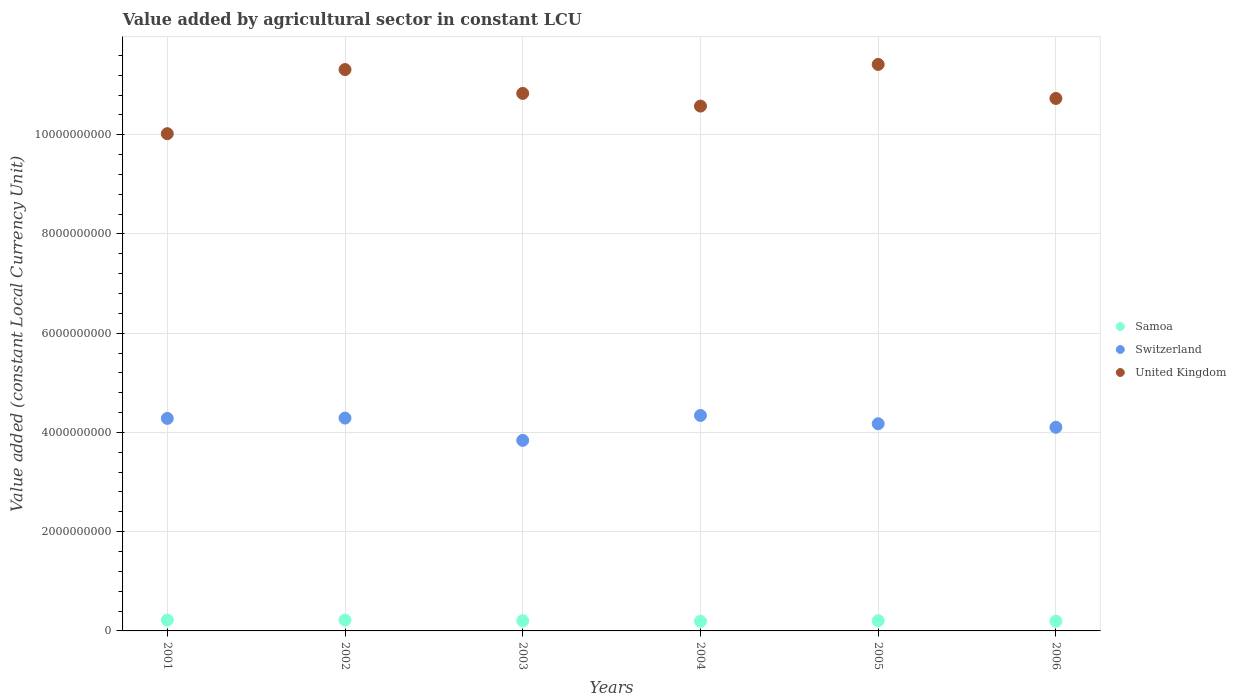How many different coloured dotlines are there?
Your response must be concise. 3. Is the number of dotlines equal to the number of legend labels?
Your response must be concise. Yes. What is the value added by agricultural sector in United Kingdom in 2001?
Offer a very short reply. 1.00e+1. Across all years, what is the maximum value added by agricultural sector in United Kingdom?
Your answer should be very brief. 1.14e+1. Across all years, what is the minimum value added by agricultural sector in Samoa?
Offer a very short reply. 1.95e+08. In which year was the value added by agricultural sector in Switzerland minimum?
Ensure brevity in your answer.  2003. What is the total value added by agricultural sector in United Kingdom in the graph?
Your answer should be very brief. 6.49e+1. What is the difference between the value added by agricultural sector in United Kingdom in 2001 and that in 2005?
Give a very brief answer. -1.40e+09. What is the difference between the value added by agricultural sector in Switzerland in 2006 and the value added by agricultural sector in United Kingdom in 2004?
Make the answer very short. -6.47e+09. What is the average value added by agricultural sector in Samoa per year?
Give a very brief answer. 2.07e+08. In the year 2002, what is the difference between the value added by agricultural sector in Switzerland and value added by agricultural sector in Samoa?
Provide a succinct answer. 4.07e+09. What is the ratio of the value added by agricultural sector in Switzerland in 2004 to that in 2006?
Offer a very short reply. 1.06. What is the difference between the highest and the second highest value added by agricultural sector in Samoa?
Your response must be concise. 2.29e+05. What is the difference between the highest and the lowest value added by agricultural sector in Switzerland?
Provide a short and direct response. 5.02e+08. Is it the case that in every year, the sum of the value added by agricultural sector in Switzerland and value added by agricultural sector in United Kingdom  is greater than the value added by agricultural sector in Samoa?
Your response must be concise. Yes. Does the value added by agricultural sector in Samoa monotonically increase over the years?
Keep it short and to the point. No. Is the value added by agricultural sector in Samoa strictly greater than the value added by agricultural sector in United Kingdom over the years?
Your response must be concise. No. Is the value added by agricultural sector in Switzerland strictly less than the value added by agricultural sector in Samoa over the years?
Offer a very short reply. No. How many dotlines are there?
Your answer should be very brief. 3. What is the difference between two consecutive major ticks on the Y-axis?
Offer a very short reply. 2.00e+09. Are the values on the major ticks of Y-axis written in scientific E-notation?
Provide a short and direct response. No. Does the graph contain grids?
Ensure brevity in your answer.  Yes. How many legend labels are there?
Provide a succinct answer. 3. How are the legend labels stacked?
Your answer should be very brief. Vertical. What is the title of the graph?
Make the answer very short. Value added by agricultural sector in constant LCU. Does "Algeria" appear as one of the legend labels in the graph?
Make the answer very short. No. What is the label or title of the Y-axis?
Keep it short and to the point. Value added (constant Local Currency Unit). What is the Value added (constant Local Currency Unit) in Samoa in 2001?
Your answer should be compact. 2.19e+08. What is the Value added (constant Local Currency Unit) in Switzerland in 2001?
Make the answer very short. 4.28e+09. What is the Value added (constant Local Currency Unit) of United Kingdom in 2001?
Keep it short and to the point. 1.00e+1. What is the Value added (constant Local Currency Unit) in Samoa in 2002?
Make the answer very short. 2.19e+08. What is the Value added (constant Local Currency Unit) of Switzerland in 2002?
Make the answer very short. 4.29e+09. What is the Value added (constant Local Currency Unit) in United Kingdom in 2002?
Give a very brief answer. 1.13e+1. What is the Value added (constant Local Currency Unit) in Samoa in 2003?
Offer a terse response. 2.05e+08. What is the Value added (constant Local Currency Unit) in Switzerland in 2003?
Offer a very short reply. 3.84e+09. What is the Value added (constant Local Currency Unit) of United Kingdom in 2003?
Offer a terse response. 1.08e+1. What is the Value added (constant Local Currency Unit) of Samoa in 2004?
Give a very brief answer. 1.95e+08. What is the Value added (constant Local Currency Unit) in Switzerland in 2004?
Provide a succinct answer. 4.34e+09. What is the Value added (constant Local Currency Unit) of United Kingdom in 2004?
Ensure brevity in your answer.  1.06e+1. What is the Value added (constant Local Currency Unit) of Samoa in 2005?
Offer a very short reply. 2.06e+08. What is the Value added (constant Local Currency Unit) of Switzerland in 2005?
Your answer should be very brief. 4.18e+09. What is the Value added (constant Local Currency Unit) of United Kingdom in 2005?
Your response must be concise. 1.14e+1. What is the Value added (constant Local Currency Unit) in Samoa in 2006?
Provide a succinct answer. 1.97e+08. What is the Value added (constant Local Currency Unit) of Switzerland in 2006?
Provide a short and direct response. 4.10e+09. What is the Value added (constant Local Currency Unit) in United Kingdom in 2006?
Offer a terse response. 1.07e+1. Across all years, what is the maximum Value added (constant Local Currency Unit) in Samoa?
Make the answer very short. 2.19e+08. Across all years, what is the maximum Value added (constant Local Currency Unit) of Switzerland?
Provide a succinct answer. 4.34e+09. Across all years, what is the maximum Value added (constant Local Currency Unit) in United Kingdom?
Keep it short and to the point. 1.14e+1. Across all years, what is the minimum Value added (constant Local Currency Unit) in Samoa?
Make the answer very short. 1.95e+08. Across all years, what is the minimum Value added (constant Local Currency Unit) of Switzerland?
Your answer should be very brief. 3.84e+09. Across all years, what is the minimum Value added (constant Local Currency Unit) in United Kingdom?
Offer a very short reply. 1.00e+1. What is the total Value added (constant Local Currency Unit) of Samoa in the graph?
Your answer should be compact. 1.24e+09. What is the total Value added (constant Local Currency Unit) of Switzerland in the graph?
Give a very brief answer. 2.50e+1. What is the total Value added (constant Local Currency Unit) in United Kingdom in the graph?
Your response must be concise. 6.49e+1. What is the difference between the Value added (constant Local Currency Unit) in Samoa in 2001 and that in 2002?
Make the answer very short. 2.29e+05. What is the difference between the Value added (constant Local Currency Unit) of Switzerland in 2001 and that in 2002?
Make the answer very short. -6.54e+06. What is the difference between the Value added (constant Local Currency Unit) in United Kingdom in 2001 and that in 2002?
Make the answer very short. -1.29e+09. What is the difference between the Value added (constant Local Currency Unit) in Samoa in 2001 and that in 2003?
Offer a terse response. 1.41e+07. What is the difference between the Value added (constant Local Currency Unit) of Switzerland in 2001 and that in 2003?
Give a very brief answer. 4.43e+08. What is the difference between the Value added (constant Local Currency Unit) in United Kingdom in 2001 and that in 2003?
Provide a short and direct response. -8.12e+08. What is the difference between the Value added (constant Local Currency Unit) in Samoa in 2001 and that in 2004?
Ensure brevity in your answer.  2.45e+07. What is the difference between the Value added (constant Local Currency Unit) in Switzerland in 2001 and that in 2004?
Keep it short and to the point. -5.92e+07. What is the difference between the Value added (constant Local Currency Unit) in United Kingdom in 2001 and that in 2004?
Offer a very short reply. -5.56e+08. What is the difference between the Value added (constant Local Currency Unit) in Samoa in 2001 and that in 2005?
Provide a short and direct response. 1.35e+07. What is the difference between the Value added (constant Local Currency Unit) of Switzerland in 2001 and that in 2005?
Offer a very short reply. 1.07e+08. What is the difference between the Value added (constant Local Currency Unit) of United Kingdom in 2001 and that in 2005?
Offer a very short reply. -1.40e+09. What is the difference between the Value added (constant Local Currency Unit) in Samoa in 2001 and that in 2006?
Make the answer very short. 2.21e+07. What is the difference between the Value added (constant Local Currency Unit) of Switzerland in 2001 and that in 2006?
Your answer should be compact. 1.80e+08. What is the difference between the Value added (constant Local Currency Unit) in United Kingdom in 2001 and that in 2006?
Your response must be concise. -7.10e+08. What is the difference between the Value added (constant Local Currency Unit) of Samoa in 2002 and that in 2003?
Provide a succinct answer. 1.39e+07. What is the difference between the Value added (constant Local Currency Unit) in Switzerland in 2002 and that in 2003?
Your answer should be very brief. 4.50e+08. What is the difference between the Value added (constant Local Currency Unit) of United Kingdom in 2002 and that in 2003?
Your answer should be very brief. 4.81e+08. What is the difference between the Value added (constant Local Currency Unit) of Samoa in 2002 and that in 2004?
Keep it short and to the point. 2.42e+07. What is the difference between the Value added (constant Local Currency Unit) in Switzerland in 2002 and that in 2004?
Your answer should be very brief. -5.26e+07. What is the difference between the Value added (constant Local Currency Unit) of United Kingdom in 2002 and that in 2004?
Make the answer very short. 7.36e+08. What is the difference between the Value added (constant Local Currency Unit) of Samoa in 2002 and that in 2005?
Offer a terse response. 1.32e+07. What is the difference between the Value added (constant Local Currency Unit) in Switzerland in 2002 and that in 2005?
Your answer should be compact. 1.14e+08. What is the difference between the Value added (constant Local Currency Unit) of United Kingdom in 2002 and that in 2005?
Ensure brevity in your answer.  -1.04e+08. What is the difference between the Value added (constant Local Currency Unit) in Samoa in 2002 and that in 2006?
Your answer should be very brief. 2.19e+07. What is the difference between the Value added (constant Local Currency Unit) in Switzerland in 2002 and that in 2006?
Ensure brevity in your answer.  1.86e+08. What is the difference between the Value added (constant Local Currency Unit) in United Kingdom in 2002 and that in 2006?
Give a very brief answer. 5.82e+08. What is the difference between the Value added (constant Local Currency Unit) of Samoa in 2003 and that in 2004?
Provide a short and direct response. 1.03e+07. What is the difference between the Value added (constant Local Currency Unit) of Switzerland in 2003 and that in 2004?
Offer a very short reply. -5.02e+08. What is the difference between the Value added (constant Local Currency Unit) of United Kingdom in 2003 and that in 2004?
Keep it short and to the point. 2.56e+08. What is the difference between the Value added (constant Local Currency Unit) in Samoa in 2003 and that in 2005?
Provide a succinct answer. -6.86e+05. What is the difference between the Value added (constant Local Currency Unit) of Switzerland in 2003 and that in 2005?
Give a very brief answer. -3.36e+08. What is the difference between the Value added (constant Local Currency Unit) in United Kingdom in 2003 and that in 2005?
Your response must be concise. -5.84e+08. What is the difference between the Value added (constant Local Currency Unit) in Samoa in 2003 and that in 2006?
Give a very brief answer. 8.00e+06. What is the difference between the Value added (constant Local Currency Unit) in Switzerland in 2003 and that in 2006?
Make the answer very short. -2.64e+08. What is the difference between the Value added (constant Local Currency Unit) of United Kingdom in 2003 and that in 2006?
Make the answer very short. 1.02e+08. What is the difference between the Value added (constant Local Currency Unit) in Samoa in 2004 and that in 2005?
Your answer should be very brief. -1.10e+07. What is the difference between the Value added (constant Local Currency Unit) of Switzerland in 2004 and that in 2005?
Your answer should be compact. 1.66e+08. What is the difference between the Value added (constant Local Currency Unit) of United Kingdom in 2004 and that in 2005?
Offer a terse response. -8.40e+08. What is the difference between the Value added (constant Local Currency Unit) in Samoa in 2004 and that in 2006?
Keep it short and to the point. -2.31e+06. What is the difference between the Value added (constant Local Currency Unit) in Switzerland in 2004 and that in 2006?
Ensure brevity in your answer.  2.39e+08. What is the difference between the Value added (constant Local Currency Unit) in United Kingdom in 2004 and that in 2006?
Give a very brief answer. -1.54e+08. What is the difference between the Value added (constant Local Currency Unit) of Samoa in 2005 and that in 2006?
Ensure brevity in your answer.  8.68e+06. What is the difference between the Value added (constant Local Currency Unit) of Switzerland in 2005 and that in 2006?
Give a very brief answer. 7.24e+07. What is the difference between the Value added (constant Local Currency Unit) of United Kingdom in 2005 and that in 2006?
Make the answer very short. 6.86e+08. What is the difference between the Value added (constant Local Currency Unit) in Samoa in 2001 and the Value added (constant Local Currency Unit) in Switzerland in 2002?
Provide a succinct answer. -4.07e+09. What is the difference between the Value added (constant Local Currency Unit) in Samoa in 2001 and the Value added (constant Local Currency Unit) in United Kingdom in 2002?
Offer a terse response. -1.11e+1. What is the difference between the Value added (constant Local Currency Unit) of Switzerland in 2001 and the Value added (constant Local Currency Unit) of United Kingdom in 2002?
Offer a terse response. -7.03e+09. What is the difference between the Value added (constant Local Currency Unit) of Samoa in 2001 and the Value added (constant Local Currency Unit) of Switzerland in 2003?
Your response must be concise. -3.62e+09. What is the difference between the Value added (constant Local Currency Unit) in Samoa in 2001 and the Value added (constant Local Currency Unit) in United Kingdom in 2003?
Make the answer very short. -1.06e+1. What is the difference between the Value added (constant Local Currency Unit) of Switzerland in 2001 and the Value added (constant Local Currency Unit) of United Kingdom in 2003?
Offer a terse response. -6.55e+09. What is the difference between the Value added (constant Local Currency Unit) of Samoa in 2001 and the Value added (constant Local Currency Unit) of Switzerland in 2004?
Your answer should be compact. -4.12e+09. What is the difference between the Value added (constant Local Currency Unit) of Samoa in 2001 and the Value added (constant Local Currency Unit) of United Kingdom in 2004?
Offer a very short reply. -1.04e+1. What is the difference between the Value added (constant Local Currency Unit) of Switzerland in 2001 and the Value added (constant Local Currency Unit) of United Kingdom in 2004?
Provide a succinct answer. -6.29e+09. What is the difference between the Value added (constant Local Currency Unit) in Samoa in 2001 and the Value added (constant Local Currency Unit) in Switzerland in 2005?
Offer a very short reply. -3.96e+09. What is the difference between the Value added (constant Local Currency Unit) of Samoa in 2001 and the Value added (constant Local Currency Unit) of United Kingdom in 2005?
Your answer should be compact. -1.12e+1. What is the difference between the Value added (constant Local Currency Unit) of Switzerland in 2001 and the Value added (constant Local Currency Unit) of United Kingdom in 2005?
Offer a terse response. -7.13e+09. What is the difference between the Value added (constant Local Currency Unit) of Samoa in 2001 and the Value added (constant Local Currency Unit) of Switzerland in 2006?
Give a very brief answer. -3.88e+09. What is the difference between the Value added (constant Local Currency Unit) of Samoa in 2001 and the Value added (constant Local Currency Unit) of United Kingdom in 2006?
Ensure brevity in your answer.  -1.05e+1. What is the difference between the Value added (constant Local Currency Unit) of Switzerland in 2001 and the Value added (constant Local Currency Unit) of United Kingdom in 2006?
Make the answer very short. -6.45e+09. What is the difference between the Value added (constant Local Currency Unit) of Samoa in 2002 and the Value added (constant Local Currency Unit) of Switzerland in 2003?
Keep it short and to the point. -3.62e+09. What is the difference between the Value added (constant Local Currency Unit) of Samoa in 2002 and the Value added (constant Local Currency Unit) of United Kingdom in 2003?
Ensure brevity in your answer.  -1.06e+1. What is the difference between the Value added (constant Local Currency Unit) in Switzerland in 2002 and the Value added (constant Local Currency Unit) in United Kingdom in 2003?
Keep it short and to the point. -6.54e+09. What is the difference between the Value added (constant Local Currency Unit) of Samoa in 2002 and the Value added (constant Local Currency Unit) of Switzerland in 2004?
Offer a very short reply. -4.12e+09. What is the difference between the Value added (constant Local Currency Unit) of Samoa in 2002 and the Value added (constant Local Currency Unit) of United Kingdom in 2004?
Your answer should be compact. -1.04e+1. What is the difference between the Value added (constant Local Currency Unit) of Switzerland in 2002 and the Value added (constant Local Currency Unit) of United Kingdom in 2004?
Give a very brief answer. -6.29e+09. What is the difference between the Value added (constant Local Currency Unit) in Samoa in 2002 and the Value added (constant Local Currency Unit) in Switzerland in 2005?
Ensure brevity in your answer.  -3.96e+09. What is the difference between the Value added (constant Local Currency Unit) of Samoa in 2002 and the Value added (constant Local Currency Unit) of United Kingdom in 2005?
Give a very brief answer. -1.12e+1. What is the difference between the Value added (constant Local Currency Unit) of Switzerland in 2002 and the Value added (constant Local Currency Unit) of United Kingdom in 2005?
Your answer should be compact. -7.13e+09. What is the difference between the Value added (constant Local Currency Unit) of Samoa in 2002 and the Value added (constant Local Currency Unit) of Switzerland in 2006?
Your answer should be very brief. -3.89e+09. What is the difference between the Value added (constant Local Currency Unit) of Samoa in 2002 and the Value added (constant Local Currency Unit) of United Kingdom in 2006?
Your response must be concise. -1.05e+1. What is the difference between the Value added (constant Local Currency Unit) of Switzerland in 2002 and the Value added (constant Local Currency Unit) of United Kingdom in 2006?
Your answer should be very brief. -6.44e+09. What is the difference between the Value added (constant Local Currency Unit) of Samoa in 2003 and the Value added (constant Local Currency Unit) of Switzerland in 2004?
Give a very brief answer. -4.14e+09. What is the difference between the Value added (constant Local Currency Unit) in Samoa in 2003 and the Value added (constant Local Currency Unit) in United Kingdom in 2004?
Provide a short and direct response. -1.04e+1. What is the difference between the Value added (constant Local Currency Unit) of Switzerland in 2003 and the Value added (constant Local Currency Unit) of United Kingdom in 2004?
Provide a short and direct response. -6.74e+09. What is the difference between the Value added (constant Local Currency Unit) of Samoa in 2003 and the Value added (constant Local Currency Unit) of Switzerland in 2005?
Your response must be concise. -3.97e+09. What is the difference between the Value added (constant Local Currency Unit) in Samoa in 2003 and the Value added (constant Local Currency Unit) in United Kingdom in 2005?
Give a very brief answer. -1.12e+1. What is the difference between the Value added (constant Local Currency Unit) in Switzerland in 2003 and the Value added (constant Local Currency Unit) in United Kingdom in 2005?
Provide a short and direct response. -7.58e+09. What is the difference between the Value added (constant Local Currency Unit) in Samoa in 2003 and the Value added (constant Local Currency Unit) in Switzerland in 2006?
Make the answer very short. -3.90e+09. What is the difference between the Value added (constant Local Currency Unit) of Samoa in 2003 and the Value added (constant Local Currency Unit) of United Kingdom in 2006?
Your answer should be compact. -1.05e+1. What is the difference between the Value added (constant Local Currency Unit) of Switzerland in 2003 and the Value added (constant Local Currency Unit) of United Kingdom in 2006?
Your answer should be compact. -6.89e+09. What is the difference between the Value added (constant Local Currency Unit) of Samoa in 2004 and the Value added (constant Local Currency Unit) of Switzerland in 2005?
Provide a succinct answer. -3.98e+09. What is the difference between the Value added (constant Local Currency Unit) in Samoa in 2004 and the Value added (constant Local Currency Unit) in United Kingdom in 2005?
Offer a terse response. -1.12e+1. What is the difference between the Value added (constant Local Currency Unit) in Switzerland in 2004 and the Value added (constant Local Currency Unit) in United Kingdom in 2005?
Offer a very short reply. -7.08e+09. What is the difference between the Value added (constant Local Currency Unit) of Samoa in 2004 and the Value added (constant Local Currency Unit) of Switzerland in 2006?
Your response must be concise. -3.91e+09. What is the difference between the Value added (constant Local Currency Unit) in Samoa in 2004 and the Value added (constant Local Currency Unit) in United Kingdom in 2006?
Provide a succinct answer. -1.05e+1. What is the difference between the Value added (constant Local Currency Unit) of Switzerland in 2004 and the Value added (constant Local Currency Unit) of United Kingdom in 2006?
Provide a succinct answer. -6.39e+09. What is the difference between the Value added (constant Local Currency Unit) in Samoa in 2005 and the Value added (constant Local Currency Unit) in Switzerland in 2006?
Offer a very short reply. -3.90e+09. What is the difference between the Value added (constant Local Currency Unit) in Samoa in 2005 and the Value added (constant Local Currency Unit) in United Kingdom in 2006?
Your response must be concise. -1.05e+1. What is the difference between the Value added (constant Local Currency Unit) of Switzerland in 2005 and the Value added (constant Local Currency Unit) of United Kingdom in 2006?
Provide a succinct answer. -6.56e+09. What is the average Value added (constant Local Currency Unit) in Samoa per year?
Provide a succinct answer. 2.07e+08. What is the average Value added (constant Local Currency Unit) of Switzerland per year?
Offer a terse response. 4.17e+09. What is the average Value added (constant Local Currency Unit) in United Kingdom per year?
Provide a short and direct response. 1.08e+1. In the year 2001, what is the difference between the Value added (constant Local Currency Unit) in Samoa and Value added (constant Local Currency Unit) in Switzerland?
Your answer should be very brief. -4.06e+09. In the year 2001, what is the difference between the Value added (constant Local Currency Unit) in Samoa and Value added (constant Local Currency Unit) in United Kingdom?
Offer a very short reply. -9.80e+09. In the year 2001, what is the difference between the Value added (constant Local Currency Unit) of Switzerland and Value added (constant Local Currency Unit) of United Kingdom?
Offer a terse response. -5.74e+09. In the year 2002, what is the difference between the Value added (constant Local Currency Unit) in Samoa and Value added (constant Local Currency Unit) in Switzerland?
Your answer should be compact. -4.07e+09. In the year 2002, what is the difference between the Value added (constant Local Currency Unit) of Samoa and Value added (constant Local Currency Unit) of United Kingdom?
Ensure brevity in your answer.  -1.11e+1. In the year 2002, what is the difference between the Value added (constant Local Currency Unit) of Switzerland and Value added (constant Local Currency Unit) of United Kingdom?
Your answer should be very brief. -7.02e+09. In the year 2003, what is the difference between the Value added (constant Local Currency Unit) in Samoa and Value added (constant Local Currency Unit) in Switzerland?
Your answer should be very brief. -3.64e+09. In the year 2003, what is the difference between the Value added (constant Local Currency Unit) in Samoa and Value added (constant Local Currency Unit) in United Kingdom?
Offer a very short reply. -1.06e+1. In the year 2003, what is the difference between the Value added (constant Local Currency Unit) in Switzerland and Value added (constant Local Currency Unit) in United Kingdom?
Provide a succinct answer. -6.99e+09. In the year 2004, what is the difference between the Value added (constant Local Currency Unit) of Samoa and Value added (constant Local Currency Unit) of Switzerland?
Give a very brief answer. -4.15e+09. In the year 2004, what is the difference between the Value added (constant Local Currency Unit) in Samoa and Value added (constant Local Currency Unit) in United Kingdom?
Make the answer very short. -1.04e+1. In the year 2004, what is the difference between the Value added (constant Local Currency Unit) of Switzerland and Value added (constant Local Currency Unit) of United Kingdom?
Offer a very short reply. -6.24e+09. In the year 2005, what is the difference between the Value added (constant Local Currency Unit) in Samoa and Value added (constant Local Currency Unit) in Switzerland?
Make the answer very short. -3.97e+09. In the year 2005, what is the difference between the Value added (constant Local Currency Unit) in Samoa and Value added (constant Local Currency Unit) in United Kingdom?
Make the answer very short. -1.12e+1. In the year 2005, what is the difference between the Value added (constant Local Currency Unit) of Switzerland and Value added (constant Local Currency Unit) of United Kingdom?
Offer a very short reply. -7.24e+09. In the year 2006, what is the difference between the Value added (constant Local Currency Unit) of Samoa and Value added (constant Local Currency Unit) of Switzerland?
Your answer should be compact. -3.91e+09. In the year 2006, what is the difference between the Value added (constant Local Currency Unit) in Samoa and Value added (constant Local Currency Unit) in United Kingdom?
Offer a very short reply. -1.05e+1. In the year 2006, what is the difference between the Value added (constant Local Currency Unit) in Switzerland and Value added (constant Local Currency Unit) in United Kingdom?
Ensure brevity in your answer.  -6.63e+09. What is the ratio of the Value added (constant Local Currency Unit) of Switzerland in 2001 to that in 2002?
Keep it short and to the point. 1. What is the ratio of the Value added (constant Local Currency Unit) of United Kingdom in 2001 to that in 2002?
Offer a very short reply. 0.89. What is the ratio of the Value added (constant Local Currency Unit) in Samoa in 2001 to that in 2003?
Give a very brief answer. 1.07. What is the ratio of the Value added (constant Local Currency Unit) of Switzerland in 2001 to that in 2003?
Keep it short and to the point. 1.12. What is the ratio of the Value added (constant Local Currency Unit) of United Kingdom in 2001 to that in 2003?
Provide a succinct answer. 0.93. What is the ratio of the Value added (constant Local Currency Unit) in Samoa in 2001 to that in 2004?
Keep it short and to the point. 1.13. What is the ratio of the Value added (constant Local Currency Unit) of Switzerland in 2001 to that in 2004?
Ensure brevity in your answer.  0.99. What is the ratio of the Value added (constant Local Currency Unit) in United Kingdom in 2001 to that in 2004?
Provide a succinct answer. 0.95. What is the ratio of the Value added (constant Local Currency Unit) of Samoa in 2001 to that in 2005?
Your response must be concise. 1.07. What is the ratio of the Value added (constant Local Currency Unit) in Switzerland in 2001 to that in 2005?
Ensure brevity in your answer.  1.03. What is the ratio of the Value added (constant Local Currency Unit) in United Kingdom in 2001 to that in 2005?
Provide a succinct answer. 0.88. What is the ratio of the Value added (constant Local Currency Unit) of Samoa in 2001 to that in 2006?
Your answer should be very brief. 1.11. What is the ratio of the Value added (constant Local Currency Unit) of Switzerland in 2001 to that in 2006?
Your response must be concise. 1.04. What is the ratio of the Value added (constant Local Currency Unit) of United Kingdom in 2001 to that in 2006?
Your response must be concise. 0.93. What is the ratio of the Value added (constant Local Currency Unit) of Samoa in 2002 to that in 2003?
Give a very brief answer. 1.07. What is the ratio of the Value added (constant Local Currency Unit) in Switzerland in 2002 to that in 2003?
Keep it short and to the point. 1.12. What is the ratio of the Value added (constant Local Currency Unit) in United Kingdom in 2002 to that in 2003?
Keep it short and to the point. 1.04. What is the ratio of the Value added (constant Local Currency Unit) in Samoa in 2002 to that in 2004?
Keep it short and to the point. 1.12. What is the ratio of the Value added (constant Local Currency Unit) in Switzerland in 2002 to that in 2004?
Provide a short and direct response. 0.99. What is the ratio of the Value added (constant Local Currency Unit) in United Kingdom in 2002 to that in 2004?
Offer a very short reply. 1.07. What is the ratio of the Value added (constant Local Currency Unit) in Samoa in 2002 to that in 2005?
Keep it short and to the point. 1.06. What is the ratio of the Value added (constant Local Currency Unit) in Switzerland in 2002 to that in 2005?
Make the answer very short. 1.03. What is the ratio of the Value added (constant Local Currency Unit) of United Kingdom in 2002 to that in 2005?
Your answer should be compact. 0.99. What is the ratio of the Value added (constant Local Currency Unit) in Samoa in 2002 to that in 2006?
Make the answer very short. 1.11. What is the ratio of the Value added (constant Local Currency Unit) of Switzerland in 2002 to that in 2006?
Provide a short and direct response. 1.05. What is the ratio of the Value added (constant Local Currency Unit) of United Kingdom in 2002 to that in 2006?
Your answer should be compact. 1.05. What is the ratio of the Value added (constant Local Currency Unit) in Samoa in 2003 to that in 2004?
Provide a short and direct response. 1.05. What is the ratio of the Value added (constant Local Currency Unit) in Switzerland in 2003 to that in 2004?
Keep it short and to the point. 0.88. What is the ratio of the Value added (constant Local Currency Unit) of United Kingdom in 2003 to that in 2004?
Make the answer very short. 1.02. What is the ratio of the Value added (constant Local Currency Unit) in Samoa in 2003 to that in 2005?
Keep it short and to the point. 1. What is the ratio of the Value added (constant Local Currency Unit) of Switzerland in 2003 to that in 2005?
Keep it short and to the point. 0.92. What is the ratio of the Value added (constant Local Currency Unit) of United Kingdom in 2003 to that in 2005?
Your answer should be very brief. 0.95. What is the ratio of the Value added (constant Local Currency Unit) of Samoa in 2003 to that in 2006?
Your answer should be compact. 1.04. What is the ratio of the Value added (constant Local Currency Unit) of Switzerland in 2003 to that in 2006?
Your answer should be very brief. 0.94. What is the ratio of the Value added (constant Local Currency Unit) of United Kingdom in 2003 to that in 2006?
Provide a succinct answer. 1.01. What is the ratio of the Value added (constant Local Currency Unit) of Samoa in 2004 to that in 2005?
Provide a succinct answer. 0.95. What is the ratio of the Value added (constant Local Currency Unit) of Switzerland in 2004 to that in 2005?
Offer a terse response. 1.04. What is the ratio of the Value added (constant Local Currency Unit) of United Kingdom in 2004 to that in 2005?
Your answer should be very brief. 0.93. What is the ratio of the Value added (constant Local Currency Unit) of Switzerland in 2004 to that in 2006?
Your response must be concise. 1.06. What is the ratio of the Value added (constant Local Currency Unit) of United Kingdom in 2004 to that in 2006?
Ensure brevity in your answer.  0.99. What is the ratio of the Value added (constant Local Currency Unit) of Samoa in 2005 to that in 2006?
Keep it short and to the point. 1.04. What is the ratio of the Value added (constant Local Currency Unit) in Switzerland in 2005 to that in 2006?
Keep it short and to the point. 1.02. What is the ratio of the Value added (constant Local Currency Unit) in United Kingdom in 2005 to that in 2006?
Give a very brief answer. 1.06. What is the difference between the highest and the second highest Value added (constant Local Currency Unit) of Samoa?
Keep it short and to the point. 2.29e+05. What is the difference between the highest and the second highest Value added (constant Local Currency Unit) in Switzerland?
Provide a succinct answer. 5.26e+07. What is the difference between the highest and the second highest Value added (constant Local Currency Unit) of United Kingdom?
Offer a terse response. 1.04e+08. What is the difference between the highest and the lowest Value added (constant Local Currency Unit) in Samoa?
Provide a succinct answer. 2.45e+07. What is the difference between the highest and the lowest Value added (constant Local Currency Unit) of Switzerland?
Make the answer very short. 5.02e+08. What is the difference between the highest and the lowest Value added (constant Local Currency Unit) in United Kingdom?
Offer a terse response. 1.40e+09. 